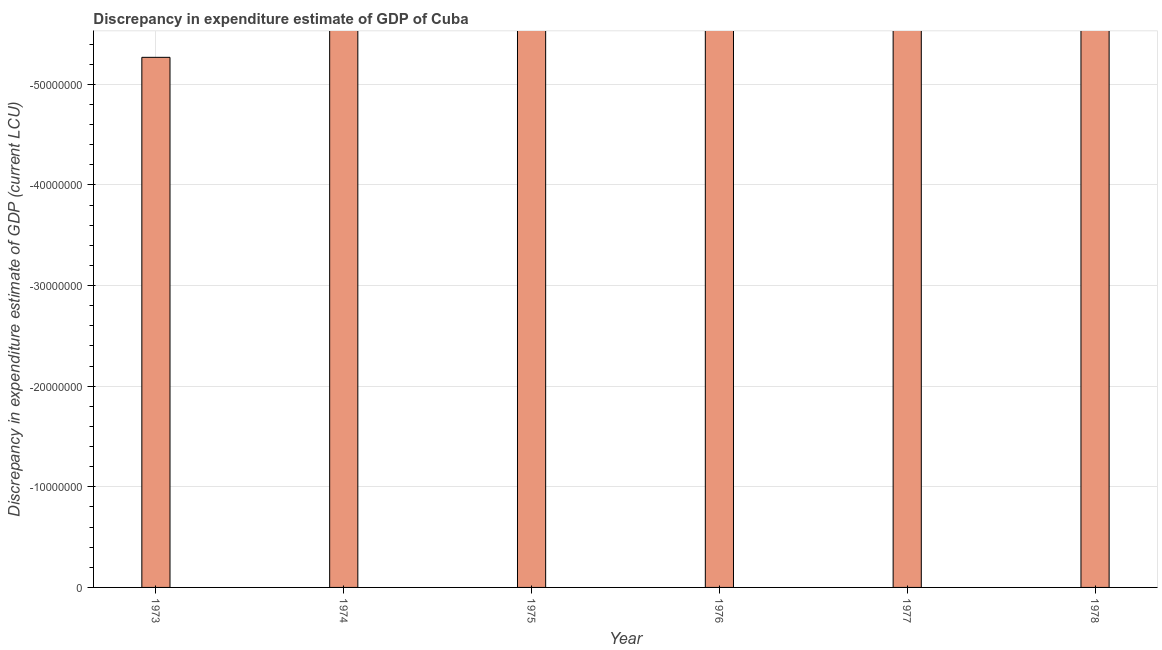What is the title of the graph?
Make the answer very short. Discrepancy in expenditure estimate of GDP of Cuba. What is the label or title of the X-axis?
Keep it short and to the point. Year. What is the label or title of the Y-axis?
Provide a succinct answer. Discrepancy in expenditure estimate of GDP (current LCU). What is the sum of the discrepancy in expenditure estimate of gdp?
Your response must be concise. 0. What is the average discrepancy in expenditure estimate of gdp per year?
Your answer should be very brief. 0. In how many years, is the discrepancy in expenditure estimate of gdp greater than -14000000 LCU?
Ensure brevity in your answer.  0. How many bars are there?
Offer a very short reply. 0. How many years are there in the graph?
Provide a succinct answer. 6. Are the values on the major ticks of Y-axis written in scientific E-notation?
Offer a terse response. No. What is the Discrepancy in expenditure estimate of GDP (current LCU) in 1973?
Offer a terse response. 0. What is the Discrepancy in expenditure estimate of GDP (current LCU) in 1975?
Give a very brief answer. 0. What is the Discrepancy in expenditure estimate of GDP (current LCU) in 1976?
Provide a succinct answer. 0. What is the Discrepancy in expenditure estimate of GDP (current LCU) of 1977?
Provide a short and direct response. 0. 